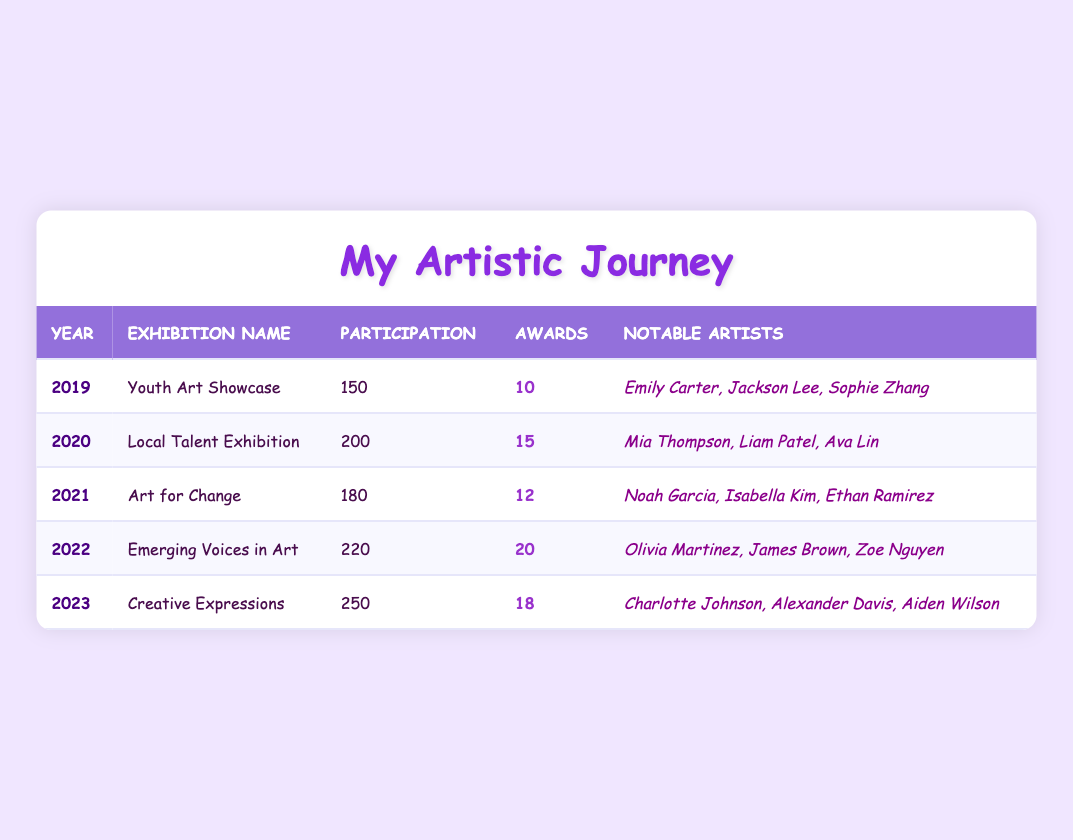What was the year with the highest number of participants? Looking at the Participation column, the highest value is 250 in 2023.
Answer: 2023 Which exhibition had the most awards given? The Awards column shows that the highest value is 20 in 2022.
Answer: 2022 How many total awards were given from 2019 to 2023? Adding the awards: 10 + 15 + 12 + 20 + 18 = 75.
Answer: 75 Was "Youth Art Showcase" awarded more than "Art for Change"? "Youth Art Showcase" had 10 awards while "Art for Change" had 12, which means "Youth Art Showcase" had fewer awards.
Answer: No What is the average participation over the five years? Summing the participation values (150 + 200 + 180 + 220 + 250 = 1080) and dividing by 5 gives an average of 1080 / 5 = 216.
Answer: 216 Which year had the least participation, and how many artists participated that year? The Participation column shows that 2019 had the least participation with 150 artists.
Answer: 2019, 150 Were there any years with participation over 200? Looking at the Participation column, 2022 (220) and 2023 (250) are both over 200.
Answer: Yes How many more awards were given in 2022 than in 2021? Subtracting the awards for these years: 20 (2022) - 12 (2021) = 8 more awards in 2022.
Answer: 8 What was the name of the exhibition in 2020? The Exhibition Name for 2020 is listed as "Local Talent Exhibition".
Answer: Local Talent Exhibition Which notable artist from the 2023 exhibition was the first to join? The notable artists listed for 2023 include Charlotte Johnson, Alexander Davis, and Aiden Wilson; there is no indication of who joined first, but they are listed in that order.
Answer: Charlotte Johnson 